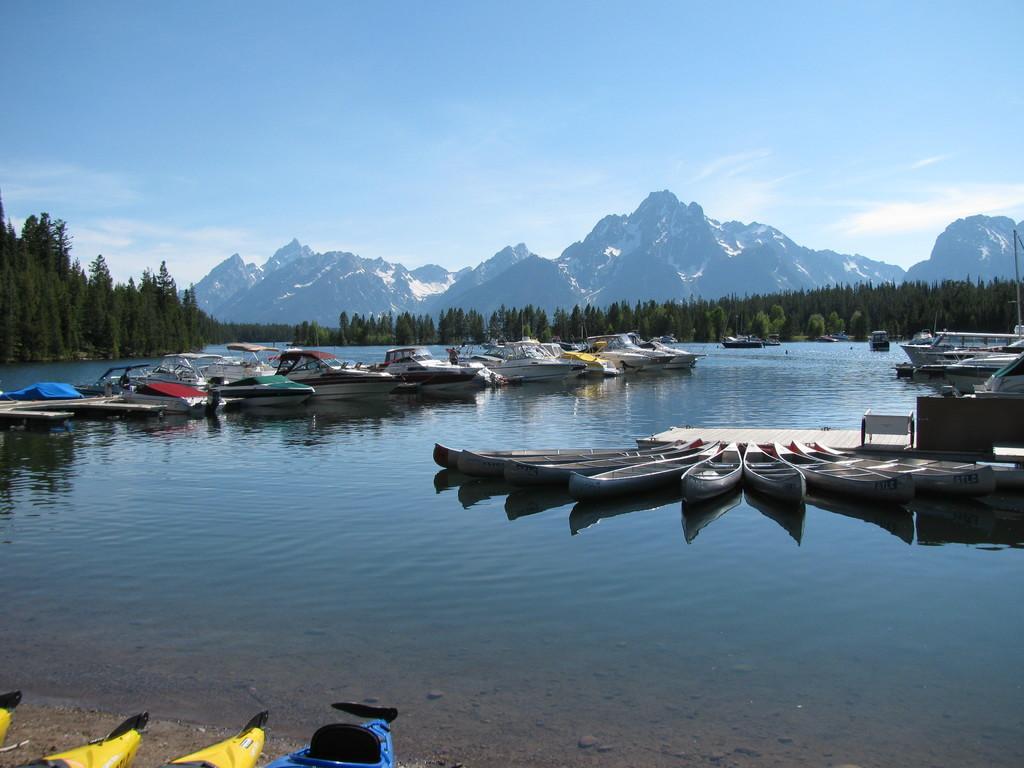Can you describe this image briefly? In this image I can see the water, few boats which are white, blue, yellow, green and red in color on the surface of the water and in the background I can see few trees, few mountains, some snow on the mountains and the sky. 